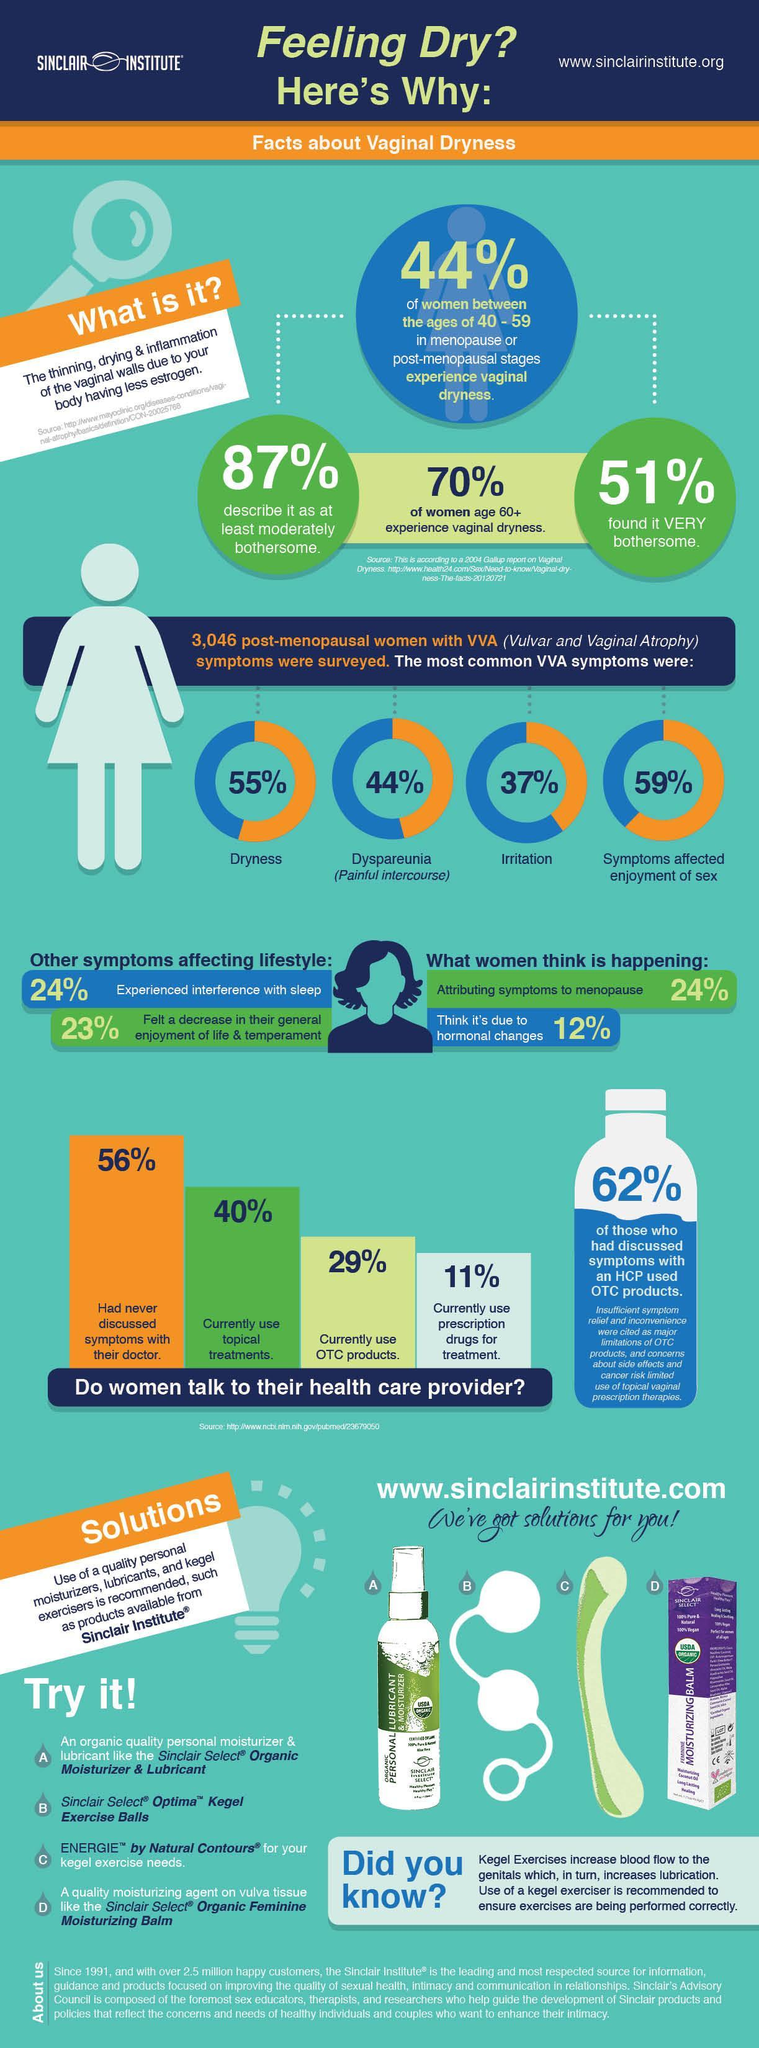What  percentage of women had irritation as the symptoms of Vulvar and Vaginal Atrophy, 55%,44%, 37%, or 59%?
Answer the question with a short phrase. 37% What percentage of women aged above 60 experienced vaginal dryness, 87%, 70%, or 51%? 70% Which products are meant to strengthen the Pelvic floor muscles? Sinclair Select Optima, ENERGIE Which is the fourth product offered by Sinclair institute? MOISTURIZING BALM 